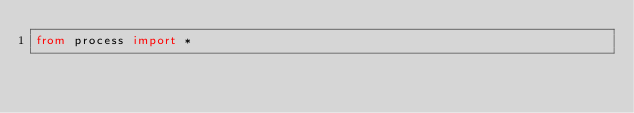Convert code to text. <code><loc_0><loc_0><loc_500><loc_500><_Python_>from process import *</code> 